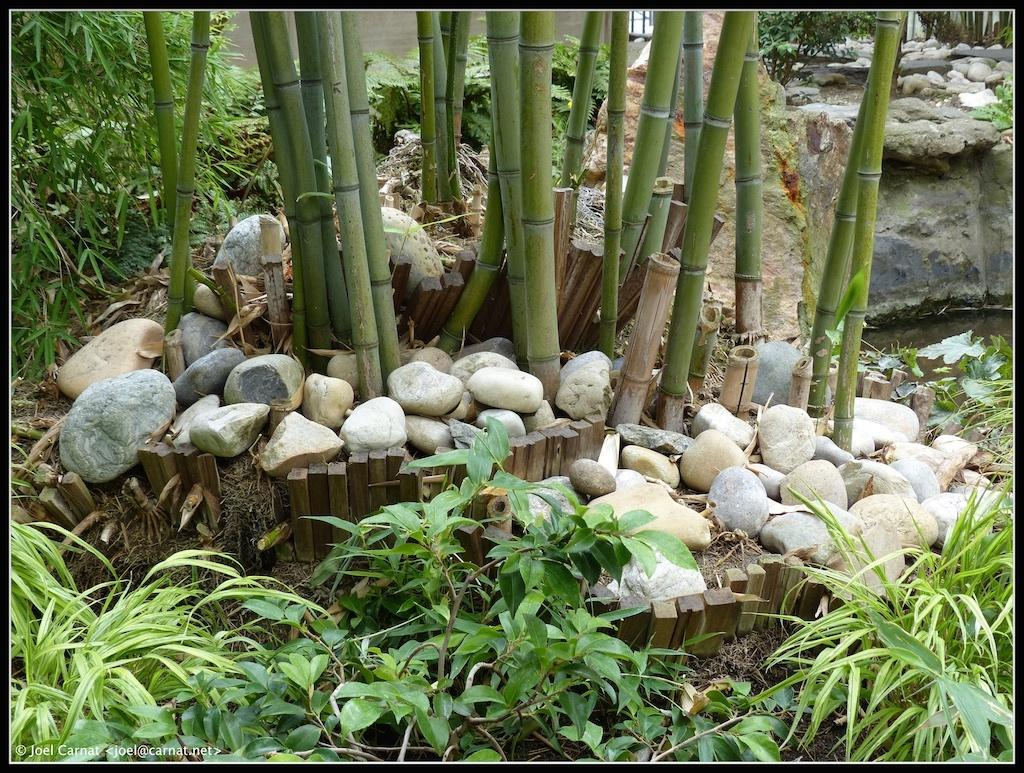What type of living organisms can be seen in the image? Plants can be seen in the image. What is surrounding the plants in the image? There are stones around the plants. What body of water is visible in the image? There is a pond on the right side of the image. What is surrounding the pond in the image? The pond is surrounded by plants. What type of grape is growing on the plants in the image? There are no grapes present in the image; only plants and stones are visible. 